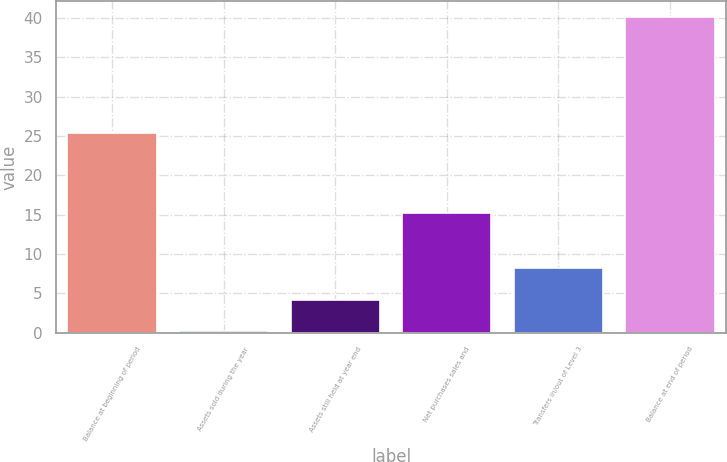<chart> <loc_0><loc_0><loc_500><loc_500><bar_chart><fcel>Balance at beginning of period<fcel>Assets sold during the year<fcel>Assets still held at year end<fcel>Net purchases sales and<fcel>Transfers in/out of Level 3<fcel>Balance at end of period<nl><fcel>25.4<fcel>0.2<fcel>4.19<fcel>15.2<fcel>8.18<fcel>40.1<nl></chart> 